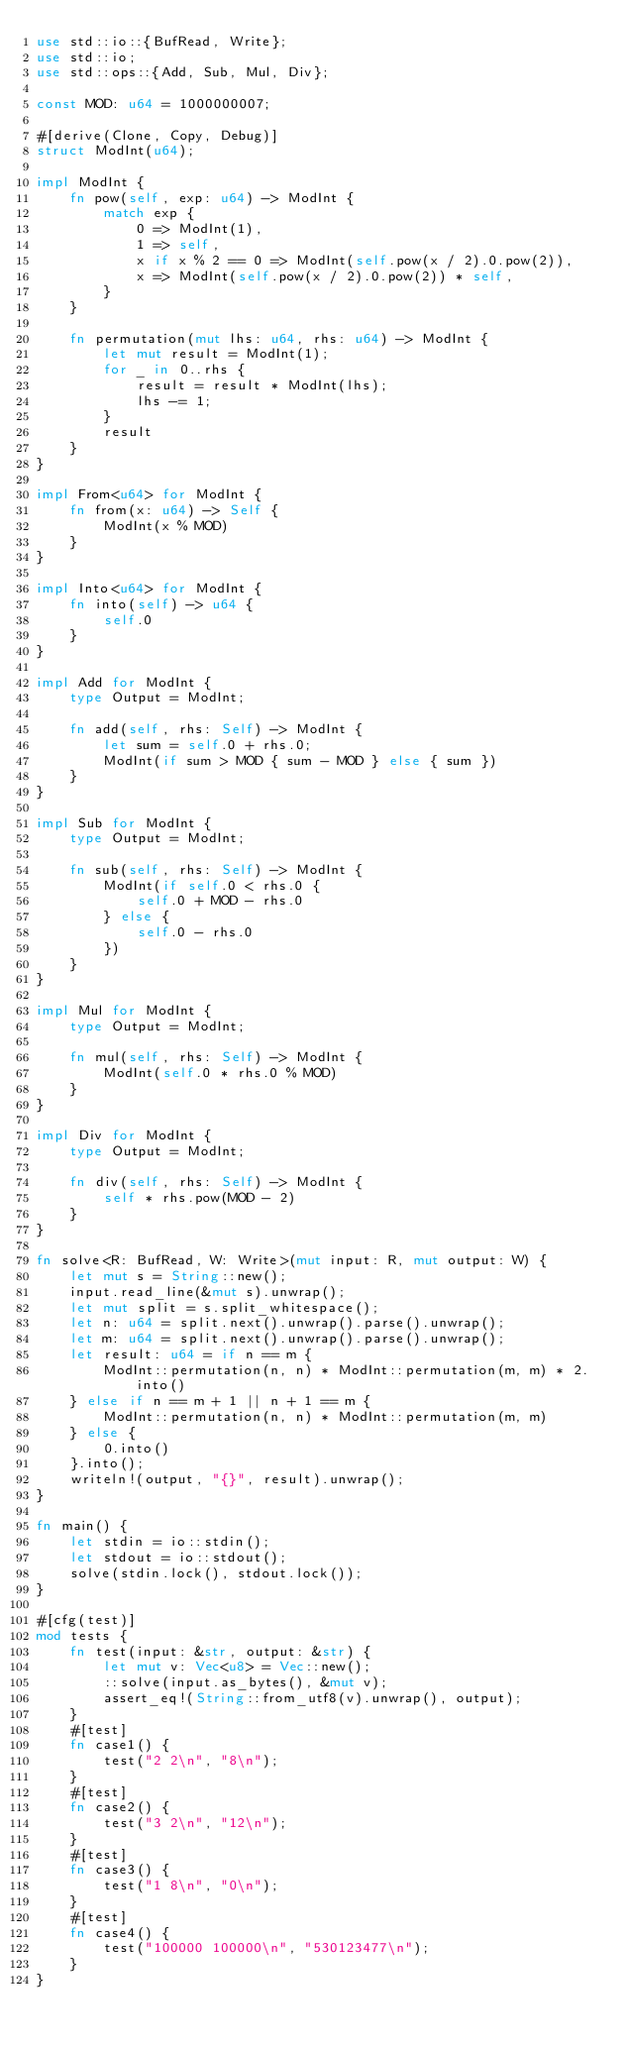Convert code to text. <code><loc_0><loc_0><loc_500><loc_500><_Rust_>use std::io::{BufRead, Write};
use std::io;
use std::ops::{Add, Sub, Mul, Div};

const MOD: u64 = 1000000007;

#[derive(Clone, Copy, Debug)]
struct ModInt(u64);

impl ModInt {
    fn pow(self, exp: u64) -> ModInt {
        match exp {
            0 => ModInt(1),
            1 => self,
            x if x % 2 == 0 => ModInt(self.pow(x / 2).0.pow(2)),
            x => ModInt(self.pow(x / 2).0.pow(2)) * self,
        }
    }

    fn permutation(mut lhs: u64, rhs: u64) -> ModInt {
        let mut result = ModInt(1);
        for _ in 0..rhs {
            result = result * ModInt(lhs);
            lhs -= 1;
        }
        result
    }
}

impl From<u64> for ModInt {
    fn from(x: u64) -> Self {
        ModInt(x % MOD)
    }
}

impl Into<u64> for ModInt {
    fn into(self) -> u64 {
        self.0
    }
}

impl Add for ModInt {
    type Output = ModInt;

    fn add(self, rhs: Self) -> ModInt {
        let sum = self.0 + rhs.0;
        ModInt(if sum > MOD { sum - MOD } else { sum })
    }
}

impl Sub for ModInt {
    type Output = ModInt;

    fn sub(self, rhs: Self) -> ModInt {
        ModInt(if self.0 < rhs.0 {
            self.0 + MOD - rhs.0
        } else {
            self.0 - rhs.0
        })
    }
}

impl Mul for ModInt {
    type Output = ModInt;

    fn mul(self, rhs: Self) -> ModInt {
        ModInt(self.0 * rhs.0 % MOD)
    }
}

impl Div for ModInt {
    type Output = ModInt;

    fn div(self, rhs: Self) -> ModInt {
        self * rhs.pow(MOD - 2)
    }
}

fn solve<R: BufRead, W: Write>(mut input: R, mut output: W) {
    let mut s = String::new();
    input.read_line(&mut s).unwrap();
    let mut split = s.split_whitespace();
    let n: u64 = split.next().unwrap().parse().unwrap();
    let m: u64 = split.next().unwrap().parse().unwrap();
    let result: u64 = if n == m {
        ModInt::permutation(n, n) * ModInt::permutation(m, m) * 2.into()
    } else if n == m + 1 || n + 1 == m {
        ModInt::permutation(n, n) * ModInt::permutation(m, m)
    } else {
        0.into()
    }.into();
    writeln!(output, "{}", result).unwrap();
}

fn main() {
    let stdin = io::stdin();
    let stdout = io::stdout();
    solve(stdin.lock(), stdout.lock());
}

#[cfg(test)]
mod tests {
    fn test(input: &str, output: &str) {
        let mut v: Vec<u8> = Vec::new();
        ::solve(input.as_bytes(), &mut v);
        assert_eq!(String::from_utf8(v).unwrap(), output);
    }
    #[test]
    fn case1() {
        test("2 2\n", "8\n");
    }
    #[test]
    fn case2() {
        test("3 2\n", "12\n");
    }
    #[test]
    fn case3() {
        test("1 8\n", "0\n");
    }
    #[test]
    fn case4() {
        test("100000 100000\n", "530123477\n");
    }
}
</code> 